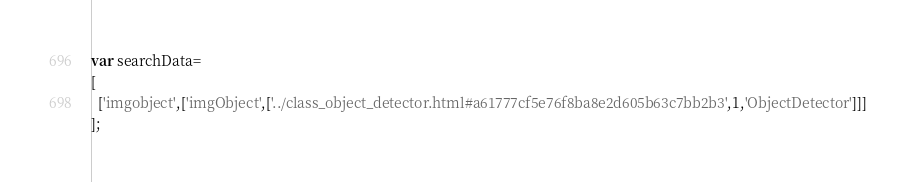Convert code to text. <code><loc_0><loc_0><loc_500><loc_500><_JavaScript_>var searchData=
[
  ['imgobject',['imgObject',['../class_object_detector.html#a61777cf5e76f8ba8e2d605b63c7bb2b3',1,'ObjectDetector']]]
];
</code> 